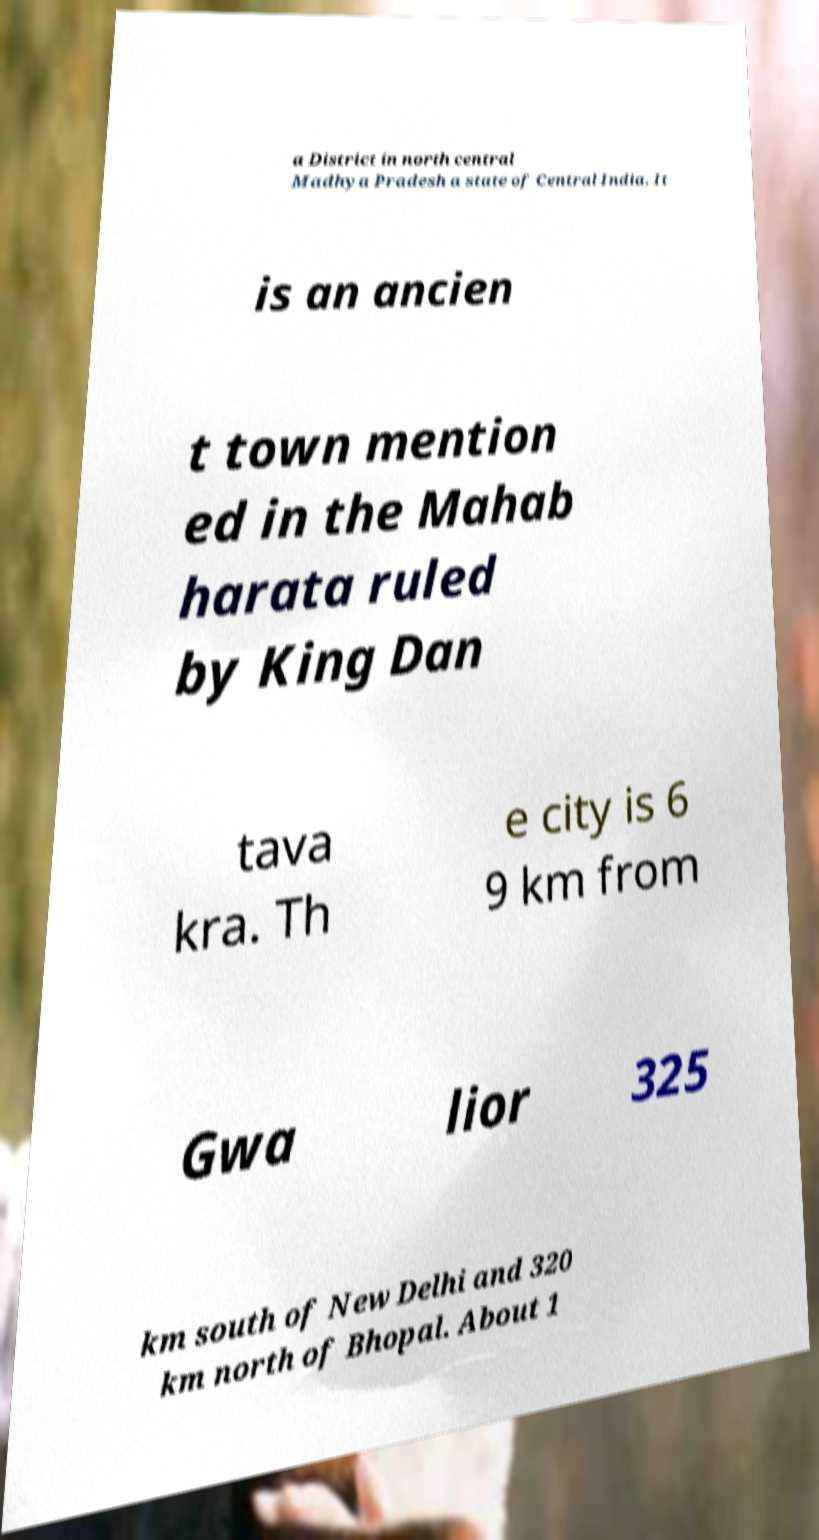Please identify and transcribe the text found in this image. a District in north central Madhya Pradesh a state of Central India. It is an ancien t town mention ed in the Mahab harata ruled by King Dan tava kra. Th e city is 6 9 km from Gwa lior 325 km south of New Delhi and 320 km north of Bhopal. About 1 